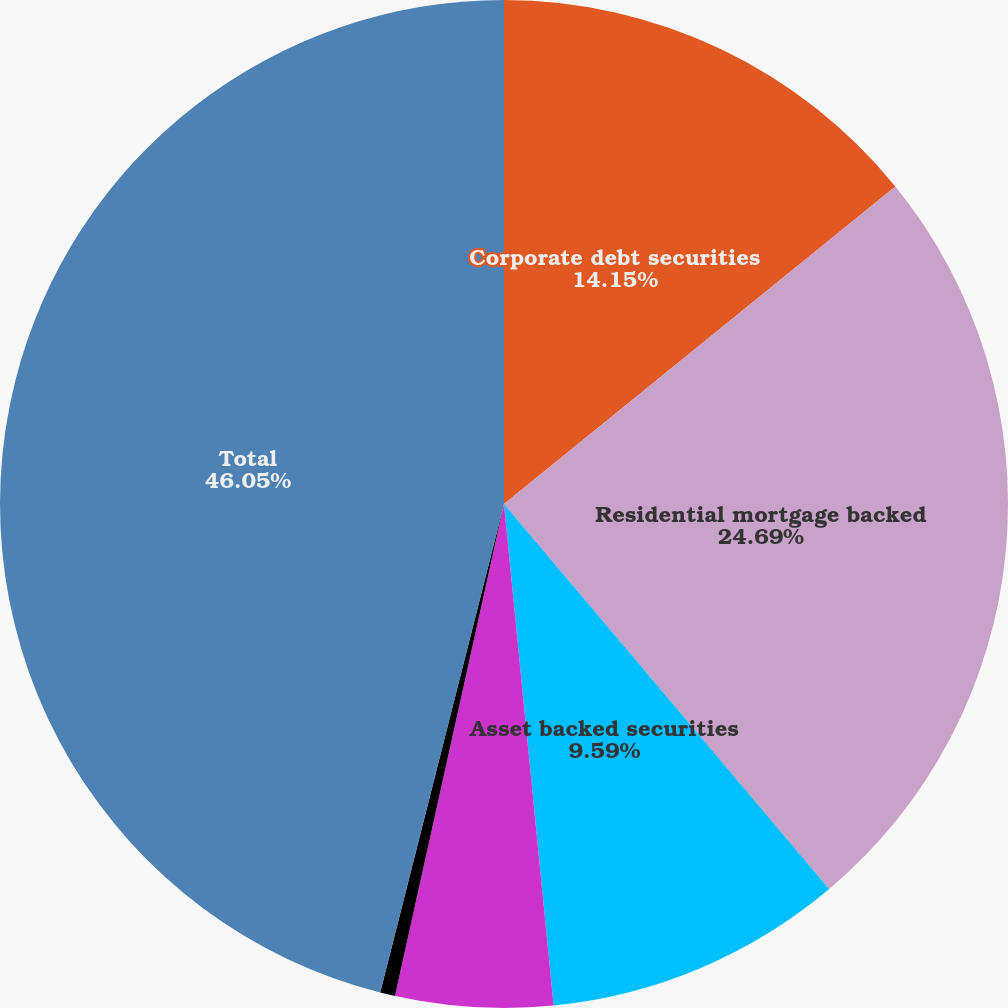Convert chart. <chart><loc_0><loc_0><loc_500><loc_500><pie_chart><fcel>Corporate debt securities<fcel>Residential mortgage backed<fcel>Asset backed securities<fcel>State and municipal<fcel>Foreign government bonds and<fcel>Total<nl><fcel>14.15%<fcel>24.69%<fcel>9.59%<fcel>5.04%<fcel>0.48%<fcel>46.05%<nl></chart> 